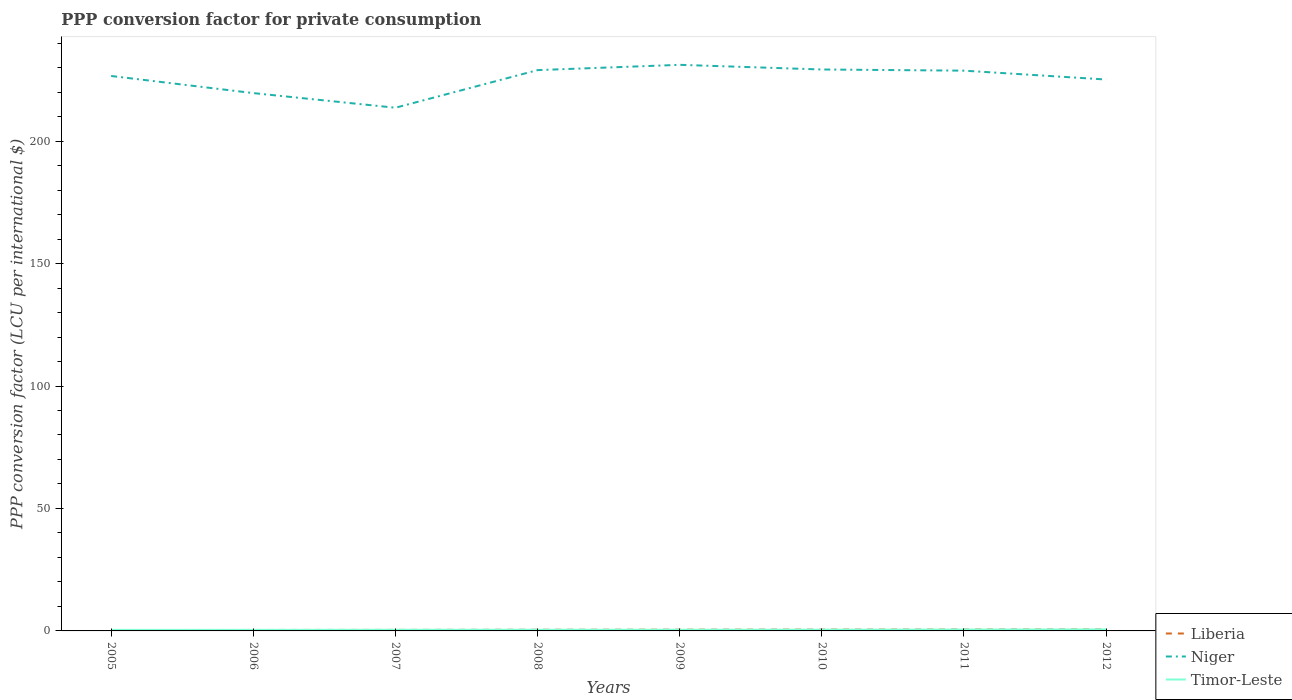Does the line corresponding to Liberia intersect with the line corresponding to Niger?
Provide a short and direct response. No. Across all years, what is the maximum PPP conversion factor for private consumption in Niger?
Provide a short and direct response. 213.62. In which year was the PPP conversion factor for private consumption in Niger maximum?
Your answer should be very brief. 2007. What is the total PPP conversion factor for private consumption in Timor-Leste in the graph?
Your response must be concise. -0.1. What is the difference between the highest and the second highest PPP conversion factor for private consumption in Timor-Leste?
Provide a short and direct response. 0.19. What is the difference between the highest and the lowest PPP conversion factor for private consumption in Timor-Leste?
Make the answer very short. 3. How many lines are there?
Keep it short and to the point. 3. How many years are there in the graph?
Make the answer very short. 8. Are the values on the major ticks of Y-axis written in scientific E-notation?
Your answer should be very brief. No. Does the graph contain any zero values?
Keep it short and to the point. No. How many legend labels are there?
Your answer should be very brief. 3. What is the title of the graph?
Your answer should be very brief. PPP conversion factor for private consumption. What is the label or title of the X-axis?
Make the answer very short. Years. What is the label or title of the Y-axis?
Provide a short and direct response. PPP conversion factor (LCU per international $). What is the PPP conversion factor (LCU per international $) of Liberia in 2005?
Offer a very short reply. 0.37. What is the PPP conversion factor (LCU per international $) of Niger in 2005?
Offer a terse response. 226.58. What is the PPP conversion factor (LCU per international $) of Timor-Leste in 2005?
Ensure brevity in your answer.  0.42. What is the PPP conversion factor (LCU per international $) of Liberia in 2006?
Your answer should be compact. 0.39. What is the PPP conversion factor (LCU per international $) of Niger in 2006?
Make the answer very short. 219.59. What is the PPP conversion factor (LCU per international $) in Timor-Leste in 2006?
Ensure brevity in your answer.  0.43. What is the PPP conversion factor (LCU per international $) in Liberia in 2007?
Your response must be concise. 0.42. What is the PPP conversion factor (LCU per international $) in Niger in 2007?
Make the answer very short. 213.62. What is the PPP conversion factor (LCU per international $) of Timor-Leste in 2007?
Ensure brevity in your answer.  0.46. What is the PPP conversion factor (LCU per international $) in Liberia in 2008?
Offer a very short reply. 0.47. What is the PPP conversion factor (LCU per international $) in Niger in 2008?
Provide a short and direct response. 228.97. What is the PPP conversion factor (LCU per international $) in Timor-Leste in 2008?
Provide a succinct answer. 0.48. What is the PPP conversion factor (LCU per international $) in Liberia in 2009?
Provide a short and direct response. 0.51. What is the PPP conversion factor (LCU per international $) in Niger in 2009?
Provide a short and direct response. 231.13. What is the PPP conversion factor (LCU per international $) of Timor-Leste in 2009?
Give a very brief answer. 0.49. What is the PPP conversion factor (LCU per international $) in Liberia in 2010?
Provide a short and direct response. 0.54. What is the PPP conversion factor (LCU per international $) of Niger in 2010?
Provide a short and direct response. 229.23. What is the PPP conversion factor (LCU per international $) of Timor-Leste in 2010?
Offer a terse response. 0.51. What is the PPP conversion factor (LCU per international $) in Liberia in 2011?
Keep it short and to the point. 0.57. What is the PPP conversion factor (LCU per international $) in Niger in 2011?
Ensure brevity in your answer.  228.75. What is the PPP conversion factor (LCU per international $) in Timor-Leste in 2011?
Make the answer very short. 0.56. What is the PPP conversion factor (LCU per international $) of Liberia in 2012?
Offer a terse response. 0.59. What is the PPP conversion factor (LCU per international $) in Niger in 2012?
Offer a terse response. 225.14. What is the PPP conversion factor (LCU per international $) in Timor-Leste in 2012?
Your answer should be compact. 0.61. Across all years, what is the maximum PPP conversion factor (LCU per international $) of Liberia?
Your answer should be very brief. 0.59. Across all years, what is the maximum PPP conversion factor (LCU per international $) in Niger?
Provide a succinct answer. 231.13. Across all years, what is the maximum PPP conversion factor (LCU per international $) of Timor-Leste?
Make the answer very short. 0.61. Across all years, what is the minimum PPP conversion factor (LCU per international $) in Liberia?
Your response must be concise. 0.37. Across all years, what is the minimum PPP conversion factor (LCU per international $) of Niger?
Offer a very short reply. 213.62. Across all years, what is the minimum PPP conversion factor (LCU per international $) of Timor-Leste?
Make the answer very short. 0.42. What is the total PPP conversion factor (LCU per international $) in Liberia in the graph?
Make the answer very short. 3.87. What is the total PPP conversion factor (LCU per international $) in Niger in the graph?
Keep it short and to the point. 1803.01. What is the total PPP conversion factor (LCU per international $) of Timor-Leste in the graph?
Your answer should be very brief. 3.96. What is the difference between the PPP conversion factor (LCU per international $) in Liberia in 2005 and that in 2006?
Keep it short and to the point. -0.01. What is the difference between the PPP conversion factor (LCU per international $) in Niger in 2005 and that in 2006?
Offer a very short reply. 6.99. What is the difference between the PPP conversion factor (LCU per international $) of Timor-Leste in 2005 and that in 2006?
Offer a terse response. -0. What is the difference between the PPP conversion factor (LCU per international $) in Liberia in 2005 and that in 2007?
Offer a terse response. -0.05. What is the difference between the PPP conversion factor (LCU per international $) of Niger in 2005 and that in 2007?
Your response must be concise. 12.97. What is the difference between the PPP conversion factor (LCU per international $) of Timor-Leste in 2005 and that in 2007?
Your response must be concise. -0.03. What is the difference between the PPP conversion factor (LCU per international $) of Liberia in 2005 and that in 2008?
Provide a succinct answer. -0.1. What is the difference between the PPP conversion factor (LCU per international $) of Niger in 2005 and that in 2008?
Keep it short and to the point. -2.39. What is the difference between the PPP conversion factor (LCU per international $) in Timor-Leste in 2005 and that in 2008?
Your answer should be compact. -0.06. What is the difference between the PPP conversion factor (LCU per international $) in Liberia in 2005 and that in 2009?
Your response must be concise. -0.14. What is the difference between the PPP conversion factor (LCU per international $) of Niger in 2005 and that in 2009?
Ensure brevity in your answer.  -4.55. What is the difference between the PPP conversion factor (LCU per international $) of Timor-Leste in 2005 and that in 2009?
Your answer should be very brief. -0.06. What is the difference between the PPP conversion factor (LCU per international $) in Liberia in 2005 and that in 2010?
Your answer should be very brief. -0.17. What is the difference between the PPP conversion factor (LCU per international $) of Niger in 2005 and that in 2010?
Offer a terse response. -2.65. What is the difference between the PPP conversion factor (LCU per international $) of Timor-Leste in 2005 and that in 2010?
Give a very brief answer. -0.09. What is the difference between the PPP conversion factor (LCU per international $) in Liberia in 2005 and that in 2011?
Keep it short and to the point. -0.2. What is the difference between the PPP conversion factor (LCU per international $) in Niger in 2005 and that in 2011?
Your response must be concise. -2.17. What is the difference between the PPP conversion factor (LCU per international $) of Timor-Leste in 2005 and that in 2011?
Offer a terse response. -0.14. What is the difference between the PPP conversion factor (LCU per international $) of Liberia in 2005 and that in 2012?
Your response must be concise. -0.22. What is the difference between the PPP conversion factor (LCU per international $) in Niger in 2005 and that in 2012?
Offer a terse response. 1.45. What is the difference between the PPP conversion factor (LCU per international $) of Timor-Leste in 2005 and that in 2012?
Keep it short and to the point. -0.19. What is the difference between the PPP conversion factor (LCU per international $) of Liberia in 2006 and that in 2007?
Give a very brief answer. -0.03. What is the difference between the PPP conversion factor (LCU per international $) in Niger in 2006 and that in 2007?
Make the answer very short. 5.98. What is the difference between the PPP conversion factor (LCU per international $) in Timor-Leste in 2006 and that in 2007?
Keep it short and to the point. -0.03. What is the difference between the PPP conversion factor (LCU per international $) in Liberia in 2006 and that in 2008?
Make the answer very short. -0.09. What is the difference between the PPP conversion factor (LCU per international $) of Niger in 2006 and that in 2008?
Provide a short and direct response. -9.38. What is the difference between the PPP conversion factor (LCU per international $) of Timor-Leste in 2006 and that in 2008?
Offer a terse response. -0.05. What is the difference between the PPP conversion factor (LCU per international $) in Liberia in 2006 and that in 2009?
Your answer should be very brief. -0.12. What is the difference between the PPP conversion factor (LCU per international $) in Niger in 2006 and that in 2009?
Your answer should be compact. -11.54. What is the difference between the PPP conversion factor (LCU per international $) in Timor-Leste in 2006 and that in 2009?
Your answer should be very brief. -0.06. What is the difference between the PPP conversion factor (LCU per international $) in Liberia in 2006 and that in 2010?
Give a very brief answer. -0.15. What is the difference between the PPP conversion factor (LCU per international $) of Niger in 2006 and that in 2010?
Ensure brevity in your answer.  -9.64. What is the difference between the PPP conversion factor (LCU per international $) in Timor-Leste in 2006 and that in 2010?
Keep it short and to the point. -0.08. What is the difference between the PPP conversion factor (LCU per international $) in Liberia in 2006 and that in 2011?
Give a very brief answer. -0.18. What is the difference between the PPP conversion factor (LCU per international $) of Niger in 2006 and that in 2011?
Provide a succinct answer. -9.16. What is the difference between the PPP conversion factor (LCU per international $) of Timor-Leste in 2006 and that in 2011?
Give a very brief answer. -0.13. What is the difference between the PPP conversion factor (LCU per international $) of Liberia in 2006 and that in 2012?
Give a very brief answer. -0.21. What is the difference between the PPP conversion factor (LCU per international $) of Niger in 2006 and that in 2012?
Make the answer very short. -5.54. What is the difference between the PPP conversion factor (LCU per international $) in Timor-Leste in 2006 and that in 2012?
Ensure brevity in your answer.  -0.19. What is the difference between the PPP conversion factor (LCU per international $) in Liberia in 2007 and that in 2008?
Offer a very short reply. -0.06. What is the difference between the PPP conversion factor (LCU per international $) in Niger in 2007 and that in 2008?
Offer a very short reply. -15.36. What is the difference between the PPP conversion factor (LCU per international $) in Timor-Leste in 2007 and that in 2008?
Offer a very short reply. -0.02. What is the difference between the PPP conversion factor (LCU per international $) in Liberia in 2007 and that in 2009?
Offer a terse response. -0.09. What is the difference between the PPP conversion factor (LCU per international $) in Niger in 2007 and that in 2009?
Your response must be concise. -17.52. What is the difference between the PPP conversion factor (LCU per international $) in Timor-Leste in 2007 and that in 2009?
Offer a terse response. -0.03. What is the difference between the PPP conversion factor (LCU per international $) in Liberia in 2007 and that in 2010?
Give a very brief answer. -0.12. What is the difference between the PPP conversion factor (LCU per international $) in Niger in 2007 and that in 2010?
Your answer should be very brief. -15.61. What is the difference between the PPP conversion factor (LCU per international $) of Timor-Leste in 2007 and that in 2010?
Ensure brevity in your answer.  -0.05. What is the difference between the PPP conversion factor (LCU per international $) in Liberia in 2007 and that in 2011?
Keep it short and to the point. -0.15. What is the difference between the PPP conversion factor (LCU per international $) in Niger in 2007 and that in 2011?
Your answer should be compact. -15.14. What is the difference between the PPP conversion factor (LCU per international $) of Timor-Leste in 2007 and that in 2011?
Your response must be concise. -0.1. What is the difference between the PPP conversion factor (LCU per international $) of Liberia in 2007 and that in 2012?
Make the answer very short. -0.17. What is the difference between the PPP conversion factor (LCU per international $) of Niger in 2007 and that in 2012?
Your response must be concise. -11.52. What is the difference between the PPP conversion factor (LCU per international $) of Timor-Leste in 2007 and that in 2012?
Your answer should be compact. -0.16. What is the difference between the PPP conversion factor (LCU per international $) in Liberia in 2008 and that in 2009?
Your answer should be very brief. -0.04. What is the difference between the PPP conversion factor (LCU per international $) of Niger in 2008 and that in 2009?
Offer a terse response. -2.16. What is the difference between the PPP conversion factor (LCU per international $) of Timor-Leste in 2008 and that in 2009?
Keep it short and to the point. -0. What is the difference between the PPP conversion factor (LCU per international $) of Liberia in 2008 and that in 2010?
Your answer should be compact. -0.07. What is the difference between the PPP conversion factor (LCU per international $) in Niger in 2008 and that in 2010?
Your answer should be compact. -0.26. What is the difference between the PPP conversion factor (LCU per international $) in Timor-Leste in 2008 and that in 2010?
Ensure brevity in your answer.  -0.03. What is the difference between the PPP conversion factor (LCU per international $) of Liberia in 2008 and that in 2011?
Provide a short and direct response. -0.09. What is the difference between the PPP conversion factor (LCU per international $) in Niger in 2008 and that in 2011?
Provide a succinct answer. 0.22. What is the difference between the PPP conversion factor (LCU per international $) of Timor-Leste in 2008 and that in 2011?
Your answer should be compact. -0.08. What is the difference between the PPP conversion factor (LCU per international $) of Liberia in 2008 and that in 2012?
Offer a terse response. -0.12. What is the difference between the PPP conversion factor (LCU per international $) in Niger in 2008 and that in 2012?
Provide a succinct answer. 3.84. What is the difference between the PPP conversion factor (LCU per international $) of Timor-Leste in 2008 and that in 2012?
Make the answer very short. -0.13. What is the difference between the PPP conversion factor (LCU per international $) of Liberia in 2009 and that in 2010?
Ensure brevity in your answer.  -0.03. What is the difference between the PPP conversion factor (LCU per international $) of Niger in 2009 and that in 2010?
Provide a succinct answer. 1.9. What is the difference between the PPP conversion factor (LCU per international $) of Timor-Leste in 2009 and that in 2010?
Your answer should be compact. -0.02. What is the difference between the PPP conversion factor (LCU per international $) in Liberia in 2009 and that in 2011?
Keep it short and to the point. -0.06. What is the difference between the PPP conversion factor (LCU per international $) of Niger in 2009 and that in 2011?
Offer a terse response. 2.38. What is the difference between the PPP conversion factor (LCU per international $) of Timor-Leste in 2009 and that in 2011?
Provide a succinct answer. -0.08. What is the difference between the PPP conversion factor (LCU per international $) in Liberia in 2009 and that in 2012?
Give a very brief answer. -0.08. What is the difference between the PPP conversion factor (LCU per international $) of Niger in 2009 and that in 2012?
Offer a very short reply. 6. What is the difference between the PPP conversion factor (LCU per international $) in Timor-Leste in 2009 and that in 2012?
Your answer should be very brief. -0.13. What is the difference between the PPP conversion factor (LCU per international $) of Liberia in 2010 and that in 2011?
Give a very brief answer. -0.03. What is the difference between the PPP conversion factor (LCU per international $) in Niger in 2010 and that in 2011?
Offer a terse response. 0.48. What is the difference between the PPP conversion factor (LCU per international $) of Timor-Leste in 2010 and that in 2011?
Your answer should be very brief. -0.05. What is the difference between the PPP conversion factor (LCU per international $) in Liberia in 2010 and that in 2012?
Give a very brief answer. -0.05. What is the difference between the PPP conversion factor (LCU per international $) in Niger in 2010 and that in 2012?
Offer a terse response. 4.09. What is the difference between the PPP conversion factor (LCU per international $) in Timor-Leste in 2010 and that in 2012?
Provide a succinct answer. -0.1. What is the difference between the PPP conversion factor (LCU per international $) of Liberia in 2011 and that in 2012?
Provide a short and direct response. -0.03. What is the difference between the PPP conversion factor (LCU per international $) of Niger in 2011 and that in 2012?
Give a very brief answer. 3.62. What is the difference between the PPP conversion factor (LCU per international $) of Timor-Leste in 2011 and that in 2012?
Give a very brief answer. -0.05. What is the difference between the PPP conversion factor (LCU per international $) in Liberia in 2005 and the PPP conversion factor (LCU per international $) in Niger in 2006?
Keep it short and to the point. -219.22. What is the difference between the PPP conversion factor (LCU per international $) of Liberia in 2005 and the PPP conversion factor (LCU per international $) of Timor-Leste in 2006?
Offer a very short reply. -0.05. What is the difference between the PPP conversion factor (LCU per international $) in Niger in 2005 and the PPP conversion factor (LCU per international $) in Timor-Leste in 2006?
Make the answer very short. 226.16. What is the difference between the PPP conversion factor (LCU per international $) of Liberia in 2005 and the PPP conversion factor (LCU per international $) of Niger in 2007?
Offer a very short reply. -213.24. What is the difference between the PPP conversion factor (LCU per international $) in Liberia in 2005 and the PPP conversion factor (LCU per international $) in Timor-Leste in 2007?
Make the answer very short. -0.09. What is the difference between the PPP conversion factor (LCU per international $) of Niger in 2005 and the PPP conversion factor (LCU per international $) of Timor-Leste in 2007?
Provide a succinct answer. 226.12. What is the difference between the PPP conversion factor (LCU per international $) in Liberia in 2005 and the PPP conversion factor (LCU per international $) in Niger in 2008?
Provide a short and direct response. -228.6. What is the difference between the PPP conversion factor (LCU per international $) in Liberia in 2005 and the PPP conversion factor (LCU per international $) in Timor-Leste in 2008?
Your answer should be compact. -0.11. What is the difference between the PPP conversion factor (LCU per international $) of Niger in 2005 and the PPP conversion factor (LCU per international $) of Timor-Leste in 2008?
Make the answer very short. 226.1. What is the difference between the PPP conversion factor (LCU per international $) in Liberia in 2005 and the PPP conversion factor (LCU per international $) in Niger in 2009?
Keep it short and to the point. -230.76. What is the difference between the PPP conversion factor (LCU per international $) in Liberia in 2005 and the PPP conversion factor (LCU per international $) in Timor-Leste in 2009?
Provide a succinct answer. -0.11. What is the difference between the PPP conversion factor (LCU per international $) in Niger in 2005 and the PPP conversion factor (LCU per international $) in Timor-Leste in 2009?
Ensure brevity in your answer.  226.1. What is the difference between the PPP conversion factor (LCU per international $) in Liberia in 2005 and the PPP conversion factor (LCU per international $) in Niger in 2010?
Ensure brevity in your answer.  -228.86. What is the difference between the PPP conversion factor (LCU per international $) in Liberia in 2005 and the PPP conversion factor (LCU per international $) in Timor-Leste in 2010?
Offer a terse response. -0.14. What is the difference between the PPP conversion factor (LCU per international $) in Niger in 2005 and the PPP conversion factor (LCU per international $) in Timor-Leste in 2010?
Offer a very short reply. 226.07. What is the difference between the PPP conversion factor (LCU per international $) of Liberia in 2005 and the PPP conversion factor (LCU per international $) of Niger in 2011?
Keep it short and to the point. -228.38. What is the difference between the PPP conversion factor (LCU per international $) of Liberia in 2005 and the PPP conversion factor (LCU per international $) of Timor-Leste in 2011?
Offer a very short reply. -0.19. What is the difference between the PPP conversion factor (LCU per international $) of Niger in 2005 and the PPP conversion factor (LCU per international $) of Timor-Leste in 2011?
Provide a short and direct response. 226.02. What is the difference between the PPP conversion factor (LCU per international $) of Liberia in 2005 and the PPP conversion factor (LCU per international $) of Niger in 2012?
Your answer should be very brief. -224.76. What is the difference between the PPP conversion factor (LCU per international $) of Liberia in 2005 and the PPP conversion factor (LCU per international $) of Timor-Leste in 2012?
Make the answer very short. -0.24. What is the difference between the PPP conversion factor (LCU per international $) in Niger in 2005 and the PPP conversion factor (LCU per international $) in Timor-Leste in 2012?
Give a very brief answer. 225.97. What is the difference between the PPP conversion factor (LCU per international $) of Liberia in 2006 and the PPP conversion factor (LCU per international $) of Niger in 2007?
Provide a short and direct response. -213.23. What is the difference between the PPP conversion factor (LCU per international $) in Liberia in 2006 and the PPP conversion factor (LCU per international $) in Timor-Leste in 2007?
Give a very brief answer. -0.07. What is the difference between the PPP conversion factor (LCU per international $) in Niger in 2006 and the PPP conversion factor (LCU per international $) in Timor-Leste in 2007?
Give a very brief answer. 219.13. What is the difference between the PPP conversion factor (LCU per international $) in Liberia in 2006 and the PPP conversion factor (LCU per international $) in Niger in 2008?
Provide a succinct answer. -228.59. What is the difference between the PPP conversion factor (LCU per international $) in Liberia in 2006 and the PPP conversion factor (LCU per international $) in Timor-Leste in 2008?
Make the answer very short. -0.09. What is the difference between the PPP conversion factor (LCU per international $) in Niger in 2006 and the PPP conversion factor (LCU per international $) in Timor-Leste in 2008?
Give a very brief answer. 219.11. What is the difference between the PPP conversion factor (LCU per international $) of Liberia in 2006 and the PPP conversion factor (LCU per international $) of Niger in 2009?
Your answer should be very brief. -230.74. What is the difference between the PPP conversion factor (LCU per international $) in Liberia in 2006 and the PPP conversion factor (LCU per international $) in Timor-Leste in 2009?
Provide a short and direct response. -0.1. What is the difference between the PPP conversion factor (LCU per international $) of Niger in 2006 and the PPP conversion factor (LCU per international $) of Timor-Leste in 2009?
Provide a succinct answer. 219.1. What is the difference between the PPP conversion factor (LCU per international $) of Liberia in 2006 and the PPP conversion factor (LCU per international $) of Niger in 2010?
Offer a very short reply. -228.84. What is the difference between the PPP conversion factor (LCU per international $) of Liberia in 2006 and the PPP conversion factor (LCU per international $) of Timor-Leste in 2010?
Provide a short and direct response. -0.12. What is the difference between the PPP conversion factor (LCU per international $) in Niger in 2006 and the PPP conversion factor (LCU per international $) in Timor-Leste in 2010?
Provide a succinct answer. 219.08. What is the difference between the PPP conversion factor (LCU per international $) of Liberia in 2006 and the PPP conversion factor (LCU per international $) of Niger in 2011?
Your response must be concise. -228.37. What is the difference between the PPP conversion factor (LCU per international $) of Liberia in 2006 and the PPP conversion factor (LCU per international $) of Timor-Leste in 2011?
Make the answer very short. -0.17. What is the difference between the PPP conversion factor (LCU per international $) in Niger in 2006 and the PPP conversion factor (LCU per international $) in Timor-Leste in 2011?
Make the answer very short. 219.03. What is the difference between the PPP conversion factor (LCU per international $) in Liberia in 2006 and the PPP conversion factor (LCU per international $) in Niger in 2012?
Keep it short and to the point. -224.75. What is the difference between the PPP conversion factor (LCU per international $) of Liberia in 2006 and the PPP conversion factor (LCU per international $) of Timor-Leste in 2012?
Your response must be concise. -0.23. What is the difference between the PPP conversion factor (LCU per international $) of Niger in 2006 and the PPP conversion factor (LCU per international $) of Timor-Leste in 2012?
Your answer should be very brief. 218.98. What is the difference between the PPP conversion factor (LCU per international $) of Liberia in 2007 and the PPP conversion factor (LCU per international $) of Niger in 2008?
Your response must be concise. -228.56. What is the difference between the PPP conversion factor (LCU per international $) in Liberia in 2007 and the PPP conversion factor (LCU per international $) in Timor-Leste in 2008?
Make the answer very short. -0.06. What is the difference between the PPP conversion factor (LCU per international $) in Niger in 2007 and the PPP conversion factor (LCU per international $) in Timor-Leste in 2008?
Your answer should be very brief. 213.13. What is the difference between the PPP conversion factor (LCU per international $) of Liberia in 2007 and the PPP conversion factor (LCU per international $) of Niger in 2009?
Provide a succinct answer. -230.71. What is the difference between the PPP conversion factor (LCU per international $) in Liberia in 2007 and the PPP conversion factor (LCU per international $) in Timor-Leste in 2009?
Ensure brevity in your answer.  -0.07. What is the difference between the PPP conversion factor (LCU per international $) of Niger in 2007 and the PPP conversion factor (LCU per international $) of Timor-Leste in 2009?
Provide a short and direct response. 213.13. What is the difference between the PPP conversion factor (LCU per international $) in Liberia in 2007 and the PPP conversion factor (LCU per international $) in Niger in 2010?
Your answer should be very brief. -228.81. What is the difference between the PPP conversion factor (LCU per international $) of Liberia in 2007 and the PPP conversion factor (LCU per international $) of Timor-Leste in 2010?
Offer a terse response. -0.09. What is the difference between the PPP conversion factor (LCU per international $) in Niger in 2007 and the PPP conversion factor (LCU per international $) in Timor-Leste in 2010?
Provide a short and direct response. 213.11. What is the difference between the PPP conversion factor (LCU per international $) of Liberia in 2007 and the PPP conversion factor (LCU per international $) of Niger in 2011?
Provide a succinct answer. -228.33. What is the difference between the PPP conversion factor (LCU per international $) in Liberia in 2007 and the PPP conversion factor (LCU per international $) in Timor-Leste in 2011?
Ensure brevity in your answer.  -0.14. What is the difference between the PPP conversion factor (LCU per international $) of Niger in 2007 and the PPP conversion factor (LCU per international $) of Timor-Leste in 2011?
Make the answer very short. 213.05. What is the difference between the PPP conversion factor (LCU per international $) in Liberia in 2007 and the PPP conversion factor (LCU per international $) in Niger in 2012?
Offer a very short reply. -224.72. What is the difference between the PPP conversion factor (LCU per international $) in Liberia in 2007 and the PPP conversion factor (LCU per international $) in Timor-Leste in 2012?
Offer a terse response. -0.2. What is the difference between the PPP conversion factor (LCU per international $) of Niger in 2007 and the PPP conversion factor (LCU per international $) of Timor-Leste in 2012?
Offer a very short reply. 213. What is the difference between the PPP conversion factor (LCU per international $) of Liberia in 2008 and the PPP conversion factor (LCU per international $) of Niger in 2009?
Provide a succinct answer. -230.66. What is the difference between the PPP conversion factor (LCU per international $) in Liberia in 2008 and the PPP conversion factor (LCU per international $) in Timor-Leste in 2009?
Offer a terse response. -0.01. What is the difference between the PPP conversion factor (LCU per international $) of Niger in 2008 and the PPP conversion factor (LCU per international $) of Timor-Leste in 2009?
Your answer should be very brief. 228.49. What is the difference between the PPP conversion factor (LCU per international $) in Liberia in 2008 and the PPP conversion factor (LCU per international $) in Niger in 2010?
Offer a very short reply. -228.76. What is the difference between the PPP conversion factor (LCU per international $) of Liberia in 2008 and the PPP conversion factor (LCU per international $) of Timor-Leste in 2010?
Your response must be concise. -0.04. What is the difference between the PPP conversion factor (LCU per international $) in Niger in 2008 and the PPP conversion factor (LCU per international $) in Timor-Leste in 2010?
Provide a short and direct response. 228.46. What is the difference between the PPP conversion factor (LCU per international $) of Liberia in 2008 and the PPP conversion factor (LCU per international $) of Niger in 2011?
Your answer should be compact. -228.28. What is the difference between the PPP conversion factor (LCU per international $) in Liberia in 2008 and the PPP conversion factor (LCU per international $) in Timor-Leste in 2011?
Offer a very short reply. -0.09. What is the difference between the PPP conversion factor (LCU per international $) of Niger in 2008 and the PPP conversion factor (LCU per international $) of Timor-Leste in 2011?
Your answer should be compact. 228.41. What is the difference between the PPP conversion factor (LCU per international $) of Liberia in 2008 and the PPP conversion factor (LCU per international $) of Niger in 2012?
Ensure brevity in your answer.  -224.66. What is the difference between the PPP conversion factor (LCU per international $) in Liberia in 2008 and the PPP conversion factor (LCU per international $) in Timor-Leste in 2012?
Offer a terse response. -0.14. What is the difference between the PPP conversion factor (LCU per international $) in Niger in 2008 and the PPP conversion factor (LCU per international $) in Timor-Leste in 2012?
Offer a very short reply. 228.36. What is the difference between the PPP conversion factor (LCU per international $) of Liberia in 2009 and the PPP conversion factor (LCU per international $) of Niger in 2010?
Offer a very short reply. -228.72. What is the difference between the PPP conversion factor (LCU per international $) of Liberia in 2009 and the PPP conversion factor (LCU per international $) of Timor-Leste in 2010?
Provide a succinct answer. 0. What is the difference between the PPP conversion factor (LCU per international $) of Niger in 2009 and the PPP conversion factor (LCU per international $) of Timor-Leste in 2010?
Provide a short and direct response. 230.62. What is the difference between the PPP conversion factor (LCU per international $) in Liberia in 2009 and the PPP conversion factor (LCU per international $) in Niger in 2011?
Provide a succinct answer. -228.24. What is the difference between the PPP conversion factor (LCU per international $) in Liberia in 2009 and the PPP conversion factor (LCU per international $) in Timor-Leste in 2011?
Give a very brief answer. -0.05. What is the difference between the PPP conversion factor (LCU per international $) in Niger in 2009 and the PPP conversion factor (LCU per international $) in Timor-Leste in 2011?
Your response must be concise. 230.57. What is the difference between the PPP conversion factor (LCU per international $) in Liberia in 2009 and the PPP conversion factor (LCU per international $) in Niger in 2012?
Ensure brevity in your answer.  -224.62. What is the difference between the PPP conversion factor (LCU per international $) in Liberia in 2009 and the PPP conversion factor (LCU per international $) in Timor-Leste in 2012?
Give a very brief answer. -0.1. What is the difference between the PPP conversion factor (LCU per international $) of Niger in 2009 and the PPP conversion factor (LCU per international $) of Timor-Leste in 2012?
Give a very brief answer. 230.52. What is the difference between the PPP conversion factor (LCU per international $) of Liberia in 2010 and the PPP conversion factor (LCU per international $) of Niger in 2011?
Offer a terse response. -228.21. What is the difference between the PPP conversion factor (LCU per international $) in Liberia in 2010 and the PPP conversion factor (LCU per international $) in Timor-Leste in 2011?
Provide a short and direct response. -0.02. What is the difference between the PPP conversion factor (LCU per international $) in Niger in 2010 and the PPP conversion factor (LCU per international $) in Timor-Leste in 2011?
Offer a terse response. 228.67. What is the difference between the PPP conversion factor (LCU per international $) in Liberia in 2010 and the PPP conversion factor (LCU per international $) in Niger in 2012?
Ensure brevity in your answer.  -224.6. What is the difference between the PPP conversion factor (LCU per international $) in Liberia in 2010 and the PPP conversion factor (LCU per international $) in Timor-Leste in 2012?
Offer a very short reply. -0.07. What is the difference between the PPP conversion factor (LCU per international $) of Niger in 2010 and the PPP conversion factor (LCU per international $) of Timor-Leste in 2012?
Give a very brief answer. 228.61. What is the difference between the PPP conversion factor (LCU per international $) of Liberia in 2011 and the PPP conversion factor (LCU per international $) of Niger in 2012?
Provide a succinct answer. -224.57. What is the difference between the PPP conversion factor (LCU per international $) in Liberia in 2011 and the PPP conversion factor (LCU per international $) in Timor-Leste in 2012?
Your answer should be compact. -0.05. What is the difference between the PPP conversion factor (LCU per international $) in Niger in 2011 and the PPP conversion factor (LCU per international $) in Timor-Leste in 2012?
Offer a terse response. 228.14. What is the average PPP conversion factor (LCU per international $) in Liberia per year?
Offer a terse response. 0.48. What is the average PPP conversion factor (LCU per international $) of Niger per year?
Your answer should be compact. 225.38. What is the average PPP conversion factor (LCU per international $) of Timor-Leste per year?
Give a very brief answer. 0.5. In the year 2005, what is the difference between the PPP conversion factor (LCU per international $) in Liberia and PPP conversion factor (LCU per international $) in Niger?
Make the answer very short. -226.21. In the year 2005, what is the difference between the PPP conversion factor (LCU per international $) in Liberia and PPP conversion factor (LCU per international $) in Timor-Leste?
Keep it short and to the point. -0.05. In the year 2005, what is the difference between the PPP conversion factor (LCU per international $) of Niger and PPP conversion factor (LCU per international $) of Timor-Leste?
Provide a succinct answer. 226.16. In the year 2006, what is the difference between the PPP conversion factor (LCU per international $) of Liberia and PPP conversion factor (LCU per international $) of Niger?
Give a very brief answer. -219.2. In the year 2006, what is the difference between the PPP conversion factor (LCU per international $) in Liberia and PPP conversion factor (LCU per international $) in Timor-Leste?
Give a very brief answer. -0.04. In the year 2006, what is the difference between the PPP conversion factor (LCU per international $) of Niger and PPP conversion factor (LCU per international $) of Timor-Leste?
Give a very brief answer. 219.16. In the year 2007, what is the difference between the PPP conversion factor (LCU per international $) of Liberia and PPP conversion factor (LCU per international $) of Niger?
Your answer should be compact. -213.2. In the year 2007, what is the difference between the PPP conversion factor (LCU per international $) in Liberia and PPP conversion factor (LCU per international $) in Timor-Leste?
Give a very brief answer. -0.04. In the year 2007, what is the difference between the PPP conversion factor (LCU per international $) of Niger and PPP conversion factor (LCU per international $) of Timor-Leste?
Your answer should be very brief. 213.16. In the year 2008, what is the difference between the PPP conversion factor (LCU per international $) of Liberia and PPP conversion factor (LCU per international $) of Niger?
Provide a succinct answer. -228.5. In the year 2008, what is the difference between the PPP conversion factor (LCU per international $) in Liberia and PPP conversion factor (LCU per international $) in Timor-Leste?
Provide a succinct answer. -0.01. In the year 2008, what is the difference between the PPP conversion factor (LCU per international $) of Niger and PPP conversion factor (LCU per international $) of Timor-Leste?
Provide a short and direct response. 228.49. In the year 2009, what is the difference between the PPP conversion factor (LCU per international $) of Liberia and PPP conversion factor (LCU per international $) of Niger?
Your response must be concise. -230.62. In the year 2009, what is the difference between the PPP conversion factor (LCU per international $) in Liberia and PPP conversion factor (LCU per international $) in Timor-Leste?
Provide a succinct answer. 0.03. In the year 2009, what is the difference between the PPP conversion factor (LCU per international $) in Niger and PPP conversion factor (LCU per international $) in Timor-Leste?
Your response must be concise. 230.65. In the year 2010, what is the difference between the PPP conversion factor (LCU per international $) of Liberia and PPP conversion factor (LCU per international $) of Niger?
Your answer should be very brief. -228.69. In the year 2010, what is the difference between the PPP conversion factor (LCU per international $) of Liberia and PPP conversion factor (LCU per international $) of Timor-Leste?
Keep it short and to the point. 0.03. In the year 2010, what is the difference between the PPP conversion factor (LCU per international $) in Niger and PPP conversion factor (LCU per international $) in Timor-Leste?
Offer a terse response. 228.72. In the year 2011, what is the difference between the PPP conversion factor (LCU per international $) of Liberia and PPP conversion factor (LCU per international $) of Niger?
Offer a very short reply. -228.19. In the year 2011, what is the difference between the PPP conversion factor (LCU per international $) in Liberia and PPP conversion factor (LCU per international $) in Timor-Leste?
Provide a short and direct response. 0.01. In the year 2011, what is the difference between the PPP conversion factor (LCU per international $) in Niger and PPP conversion factor (LCU per international $) in Timor-Leste?
Provide a succinct answer. 228.19. In the year 2012, what is the difference between the PPP conversion factor (LCU per international $) in Liberia and PPP conversion factor (LCU per international $) in Niger?
Your answer should be compact. -224.54. In the year 2012, what is the difference between the PPP conversion factor (LCU per international $) of Liberia and PPP conversion factor (LCU per international $) of Timor-Leste?
Ensure brevity in your answer.  -0.02. In the year 2012, what is the difference between the PPP conversion factor (LCU per international $) in Niger and PPP conversion factor (LCU per international $) in Timor-Leste?
Your answer should be very brief. 224.52. What is the ratio of the PPP conversion factor (LCU per international $) of Liberia in 2005 to that in 2006?
Your response must be concise. 0.96. What is the ratio of the PPP conversion factor (LCU per international $) in Niger in 2005 to that in 2006?
Provide a short and direct response. 1.03. What is the ratio of the PPP conversion factor (LCU per international $) of Liberia in 2005 to that in 2007?
Give a very brief answer. 0.89. What is the ratio of the PPP conversion factor (LCU per international $) of Niger in 2005 to that in 2007?
Provide a succinct answer. 1.06. What is the ratio of the PPP conversion factor (LCU per international $) of Timor-Leste in 2005 to that in 2007?
Your answer should be very brief. 0.93. What is the ratio of the PPP conversion factor (LCU per international $) of Liberia in 2005 to that in 2008?
Your answer should be compact. 0.78. What is the ratio of the PPP conversion factor (LCU per international $) in Timor-Leste in 2005 to that in 2008?
Ensure brevity in your answer.  0.88. What is the ratio of the PPP conversion factor (LCU per international $) in Liberia in 2005 to that in 2009?
Provide a short and direct response. 0.73. What is the ratio of the PPP conversion factor (LCU per international $) in Niger in 2005 to that in 2009?
Offer a terse response. 0.98. What is the ratio of the PPP conversion factor (LCU per international $) in Timor-Leste in 2005 to that in 2009?
Your response must be concise. 0.87. What is the ratio of the PPP conversion factor (LCU per international $) in Liberia in 2005 to that in 2010?
Offer a terse response. 0.69. What is the ratio of the PPP conversion factor (LCU per international $) of Timor-Leste in 2005 to that in 2010?
Ensure brevity in your answer.  0.83. What is the ratio of the PPP conversion factor (LCU per international $) in Liberia in 2005 to that in 2011?
Your response must be concise. 0.66. What is the ratio of the PPP conversion factor (LCU per international $) in Niger in 2005 to that in 2011?
Make the answer very short. 0.99. What is the ratio of the PPP conversion factor (LCU per international $) of Timor-Leste in 2005 to that in 2011?
Give a very brief answer. 0.76. What is the ratio of the PPP conversion factor (LCU per international $) of Liberia in 2005 to that in 2012?
Make the answer very short. 0.63. What is the ratio of the PPP conversion factor (LCU per international $) in Niger in 2005 to that in 2012?
Your response must be concise. 1.01. What is the ratio of the PPP conversion factor (LCU per international $) of Timor-Leste in 2005 to that in 2012?
Offer a terse response. 0.69. What is the ratio of the PPP conversion factor (LCU per international $) of Liberia in 2006 to that in 2007?
Keep it short and to the point. 0.92. What is the ratio of the PPP conversion factor (LCU per international $) of Niger in 2006 to that in 2007?
Offer a terse response. 1.03. What is the ratio of the PPP conversion factor (LCU per international $) of Timor-Leste in 2006 to that in 2007?
Offer a terse response. 0.93. What is the ratio of the PPP conversion factor (LCU per international $) of Liberia in 2006 to that in 2008?
Ensure brevity in your answer.  0.82. What is the ratio of the PPP conversion factor (LCU per international $) in Niger in 2006 to that in 2008?
Your response must be concise. 0.96. What is the ratio of the PPP conversion factor (LCU per international $) of Timor-Leste in 2006 to that in 2008?
Keep it short and to the point. 0.89. What is the ratio of the PPP conversion factor (LCU per international $) of Liberia in 2006 to that in 2009?
Your answer should be compact. 0.76. What is the ratio of the PPP conversion factor (LCU per international $) in Niger in 2006 to that in 2009?
Keep it short and to the point. 0.95. What is the ratio of the PPP conversion factor (LCU per international $) of Timor-Leste in 2006 to that in 2009?
Offer a terse response. 0.88. What is the ratio of the PPP conversion factor (LCU per international $) in Liberia in 2006 to that in 2010?
Keep it short and to the point. 0.72. What is the ratio of the PPP conversion factor (LCU per international $) of Niger in 2006 to that in 2010?
Your response must be concise. 0.96. What is the ratio of the PPP conversion factor (LCU per international $) of Timor-Leste in 2006 to that in 2010?
Your response must be concise. 0.84. What is the ratio of the PPP conversion factor (LCU per international $) of Liberia in 2006 to that in 2011?
Your answer should be compact. 0.68. What is the ratio of the PPP conversion factor (LCU per international $) in Niger in 2006 to that in 2011?
Offer a terse response. 0.96. What is the ratio of the PPP conversion factor (LCU per international $) in Timor-Leste in 2006 to that in 2011?
Provide a short and direct response. 0.76. What is the ratio of the PPP conversion factor (LCU per international $) in Liberia in 2006 to that in 2012?
Give a very brief answer. 0.65. What is the ratio of the PPP conversion factor (LCU per international $) in Niger in 2006 to that in 2012?
Provide a succinct answer. 0.98. What is the ratio of the PPP conversion factor (LCU per international $) of Timor-Leste in 2006 to that in 2012?
Your answer should be compact. 0.69. What is the ratio of the PPP conversion factor (LCU per international $) in Liberia in 2007 to that in 2008?
Your answer should be compact. 0.88. What is the ratio of the PPP conversion factor (LCU per international $) in Niger in 2007 to that in 2008?
Offer a very short reply. 0.93. What is the ratio of the PPP conversion factor (LCU per international $) in Timor-Leste in 2007 to that in 2008?
Your response must be concise. 0.95. What is the ratio of the PPP conversion factor (LCU per international $) of Liberia in 2007 to that in 2009?
Your answer should be very brief. 0.82. What is the ratio of the PPP conversion factor (LCU per international $) in Niger in 2007 to that in 2009?
Give a very brief answer. 0.92. What is the ratio of the PPP conversion factor (LCU per international $) of Timor-Leste in 2007 to that in 2009?
Your answer should be very brief. 0.94. What is the ratio of the PPP conversion factor (LCU per international $) of Liberia in 2007 to that in 2010?
Offer a terse response. 0.78. What is the ratio of the PPP conversion factor (LCU per international $) in Niger in 2007 to that in 2010?
Your response must be concise. 0.93. What is the ratio of the PPP conversion factor (LCU per international $) in Timor-Leste in 2007 to that in 2010?
Provide a succinct answer. 0.9. What is the ratio of the PPP conversion factor (LCU per international $) in Liberia in 2007 to that in 2011?
Offer a terse response. 0.74. What is the ratio of the PPP conversion factor (LCU per international $) of Niger in 2007 to that in 2011?
Your answer should be very brief. 0.93. What is the ratio of the PPP conversion factor (LCU per international $) in Timor-Leste in 2007 to that in 2011?
Your response must be concise. 0.82. What is the ratio of the PPP conversion factor (LCU per international $) in Liberia in 2007 to that in 2012?
Your answer should be compact. 0.71. What is the ratio of the PPP conversion factor (LCU per international $) in Niger in 2007 to that in 2012?
Ensure brevity in your answer.  0.95. What is the ratio of the PPP conversion factor (LCU per international $) in Timor-Leste in 2007 to that in 2012?
Give a very brief answer. 0.74. What is the ratio of the PPP conversion factor (LCU per international $) of Liberia in 2008 to that in 2009?
Make the answer very short. 0.93. What is the ratio of the PPP conversion factor (LCU per international $) of Niger in 2008 to that in 2009?
Give a very brief answer. 0.99. What is the ratio of the PPP conversion factor (LCU per international $) of Timor-Leste in 2008 to that in 2009?
Your response must be concise. 0.99. What is the ratio of the PPP conversion factor (LCU per international $) of Liberia in 2008 to that in 2010?
Provide a short and direct response. 0.88. What is the ratio of the PPP conversion factor (LCU per international $) of Niger in 2008 to that in 2010?
Make the answer very short. 1. What is the ratio of the PPP conversion factor (LCU per international $) of Timor-Leste in 2008 to that in 2010?
Offer a terse response. 0.94. What is the ratio of the PPP conversion factor (LCU per international $) in Liberia in 2008 to that in 2011?
Give a very brief answer. 0.84. What is the ratio of the PPP conversion factor (LCU per international $) in Timor-Leste in 2008 to that in 2011?
Make the answer very short. 0.86. What is the ratio of the PPP conversion factor (LCU per international $) in Liberia in 2008 to that in 2012?
Make the answer very short. 0.8. What is the ratio of the PPP conversion factor (LCU per international $) in Niger in 2008 to that in 2012?
Make the answer very short. 1.02. What is the ratio of the PPP conversion factor (LCU per international $) of Timor-Leste in 2008 to that in 2012?
Keep it short and to the point. 0.78. What is the ratio of the PPP conversion factor (LCU per international $) of Liberia in 2009 to that in 2010?
Provide a succinct answer. 0.95. What is the ratio of the PPP conversion factor (LCU per international $) of Niger in 2009 to that in 2010?
Offer a very short reply. 1.01. What is the ratio of the PPP conversion factor (LCU per international $) of Timor-Leste in 2009 to that in 2010?
Offer a very short reply. 0.95. What is the ratio of the PPP conversion factor (LCU per international $) of Liberia in 2009 to that in 2011?
Your answer should be very brief. 0.9. What is the ratio of the PPP conversion factor (LCU per international $) in Niger in 2009 to that in 2011?
Offer a terse response. 1.01. What is the ratio of the PPP conversion factor (LCU per international $) of Timor-Leste in 2009 to that in 2011?
Offer a very short reply. 0.87. What is the ratio of the PPP conversion factor (LCU per international $) in Liberia in 2009 to that in 2012?
Offer a terse response. 0.86. What is the ratio of the PPP conversion factor (LCU per international $) in Niger in 2009 to that in 2012?
Your answer should be compact. 1.03. What is the ratio of the PPP conversion factor (LCU per international $) of Timor-Leste in 2009 to that in 2012?
Your answer should be very brief. 0.79. What is the ratio of the PPP conversion factor (LCU per international $) in Liberia in 2010 to that in 2011?
Your response must be concise. 0.95. What is the ratio of the PPP conversion factor (LCU per international $) in Timor-Leste in 2010 to that in 2011?
Provide a succinct answer. 0.91. What is the ratio of the PPP conversion factor (LCU per international $) of Liberia in 2010 to that in 2012?
Your response must be concise. 0.91. What is the ratio of the PPP conversion factor (LCU per international $) in Niger in 2010 to that in 2012?
Make the answer very short. 1.02. What is the ratio of the PPP conversion factor (LCU per international $) of Timor-Leste in 2010 to that in 2012?
Offer a very short reply. 0.83. What is the ratio of the PPP conversion factor (LCU per international $) of Liberia in 2011 to that in 2012?
Your answer should be very brief. 0.96. What is the ratio of the PPP conversion factor (LCU per international $) in Niger in 2011 to that in 2012?
Your answer should be very brief. 1.02. What is the ratio of the PPP conversion factor (LCU per international $) in Timor-Leste in 2011 to that in 2012?
Offer a terse response. 0.91. What is the difference between the highest and the second highest PPP conversion factor (LCU per international $) in Liberia?
Your answer should be very brief. 0.03. What is the difference between the highest and the second highest PPP conversion factor (LCU per international $) of Niger?
Keep it short and to the point. 1.9. What is the difference between the highest and the second highest PPP conversion factor (LCU per international $) in Timor-Leste?
Your answer should be compact. 0.05. What is the difference between the highest and the lowest PPP conversion factor (LCU per international $) of Liberia?
Your response must be concise. 0.22. What is the difference between the highest and the lowest PPP conversion factor (LCU per international $) in Niger?
Provide a succinct answer. 17.52. What is the difference between the highest and the lowest PPP conversion factor (LCU per international $) of Timor-Leste?
Your answer should be compact. 0.19. 